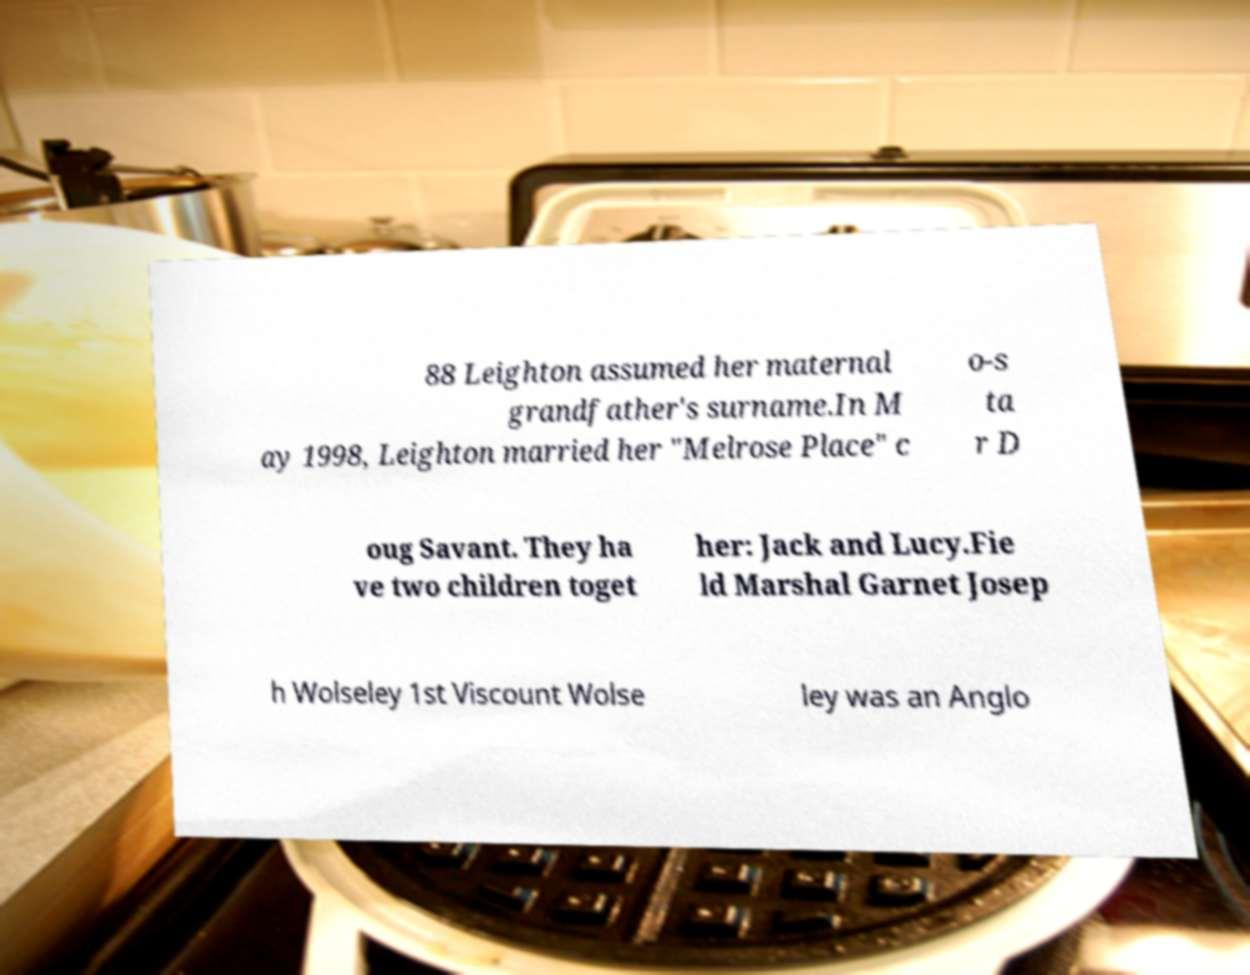For documentation purposes, I need the text within this image transcribed. Could you provide that? 88 Leighton assumed her maternal grandfather's surname.In M ay 1998, Leighton married her "Melrose Place" c o-s ta r D oug Savant. They ha ve two children toget her: Jack and Lucy.Fie ld Marshal Garnet Josep h Wolseley 1st Viscount Wolse ley was an Anglo 